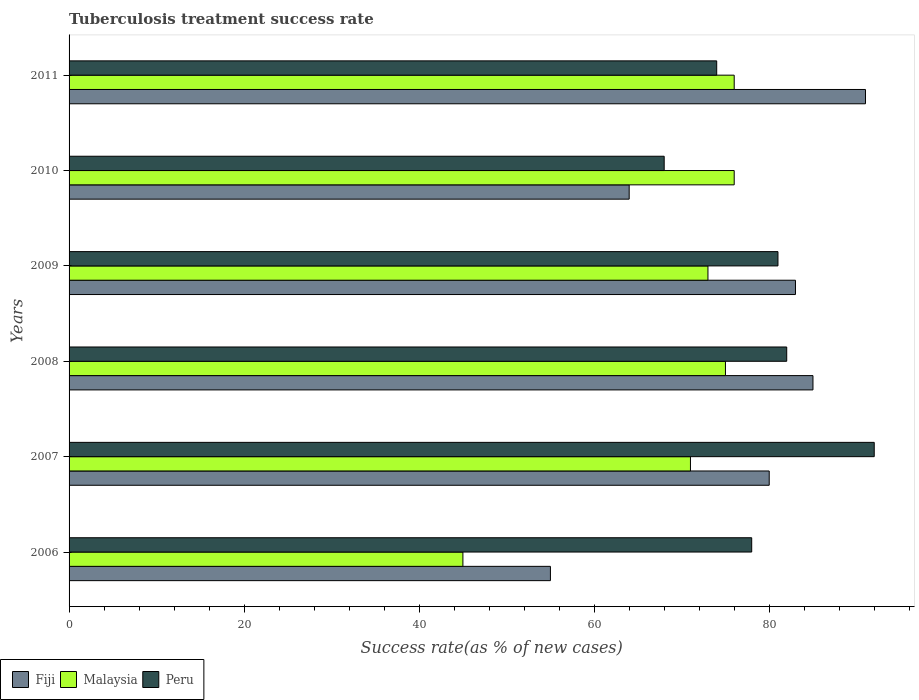Are the number of bars per tick equal to the number of legend labels?
Your answer should be very brief. Yes. What is the label of the 5th group of bars from the top?
Make the answer very short. 2007. In how many cases, is the number of bars for a given year not equal to the number of legend labels?
Your response must be concise. 0. What is the tuberculosis treatment success rate in Fiji in 2006?
Keep it short and to the point. 55. Across all years, what is the maximum tuberculosis treatment success rate in Peru?
Keep it short and to the point. 92. Across all years, what is the minimum tuberculosis treatment success rate in Fiji?
Make the answer very short. 55. In which year was the tuberculosis treatment success rate in Malaysia maximum?
Keep it short and to the point. 2010. What is the total tuberculosis treatment success rate in Peru in the graph?
Your response must be concise. 475. What is the difference between the tuberculosis treatment success rate in Peru in 2008 and that in 2011?
Your answer should be very brief. 8. What is the average tuberculosis treatment success rate in Fiji per year?
Provide a succinct answer. 76.33. In the year 2011, what is the difference between the tuberculosis treatment success rate in Malaysia and tuberculosis treatment success rate in Peru?
Your response must be concise. 2. In how many years, is the tuberculosis treatment success rate in Fiji greater than 32 %?
Offer a terse response. 6. What is the ratio of the tuberculosis treatment success rate in Fiji in 2009 to that in 2010?
Make the answer very short. 1.3. Is the difference between the tuberculosis treatment success rate in Malaysia in 2007 and 2009 greater than the difference between the tuberculosis treatment success rate in Peru in 2007 and 2009?
Keep it short and to the point. No. What is the difference between the highest and the lowest tuberculosis treatment success rate in Peru?
Your answer should be compact. 24. In how many years, is the tuberculosis treatment success rate in Fiji greater than the average tuberculosis treatment success rate in Fiji taken over all years?
Provide a short and direct response. 4. Is the sum of the tuberculosis treatment success rate in Peru in 2006 and 2010 greater than the maximum tuberculosis treatment success rate in Malaysia across all years?
Your answer should be compact. Yes. What does the 3rd bar from the bottom in 2007 represents?
Make the answer very short. Peru. Is it the case that in every year, the sum of the tuberculosis treatment success rate in Peru and tuberculosis treatment success rate in Malaysia is greater than the tuberculosis treatment success rate in Fiji?
Provide a short and direct response. Yes. Are all the bars in the graph horizontal?
Your answer should be compact. Yes. How many years are there in the graph?
Your answer should be compact. 6. What is the difference between two consecutive major ticks on the X-axis?
Your answer should be compact. 20. Where does the legend appear in the graph?
Provide a short and direct response. Bottom left. How many legend labels are there?
Provide a short and direct response. 3. How are the legend labels stacked?
Ensure brevity in your answer.  Horizontal. What is the title of the graph?
Make the answer very short. Tuberculosis treatment success rate. Does "Liechtenstein" appear as one of the legend labels in the graph?
Your answer should be compact. No. What is the label or title of the X-axis?
Keep it short and to the point. Success rate(as % of new cases). What is the Success rate(as % of new cases) of Fiji in 2006?
Your response must be concise. 55. What is the Success rate(as % of new cases) of Fiji in 2007?
Offer a very short reply. 80. What is the Success rate(as % of new cases) of Malaysia in 2007?
Provide a short and direct response. 71. What is the Success rate(as % of new cases) of Peru in 2007?
Your response must be concise. 92. What is the Success rate(as % of new cases) of Malaysia in 2008?
Provide a succinct answer. 75. What is the Success rate(as % of new cases) of Malaysia in 2009?
Provide a short and direct response. 73. What is the Success rate(as % of new cases) in Peru in 2010?
Provide a short and direct response. 68. What is the Success rate(as % of new cases) in Fiji in 2011?
Your answer should be compact. 91. What is the Success rate(as % of new cases) of Malaysia in 2011?
Provide a succinct answer. 76. What is the Success rate(as % of new cases) of Peru in 2011?
Your answer should be very brief. 74. Across all years, what is the maximum Success rate(as % of new cases) of Fiji?
Your response must be concise. 91. Across all years, what is the maximum Success rate(as % of new cases) in Malaysia?
Keep it short and to the point. 76. Across all years, what is the maximum Success rate(as % of new cases) of Peru?
Offer a very short reply. 92. Across all years, what is the minimum Success rate(as % of new cases) in Fiji?
Offer a terse response. 55. Across all years, what is the minimum Success rate(as % of new cases) of Peru?
Provide a short and direct response. 68. What is the total Success rate(as % of new cases) of Fiji in the graph?
Offer a terse response. 458. What is the total Success rate(as % of new cases) of Malaysia in the graph?
Your response must be concise. 416. What is the total Success rate(as % of new cases) in Peru in the graph?
Keep it short and to the point. 475. What is the difference between the Success rate(as % of new cases) in Fiji in 2006 and that in 2008?
Provide a short and direct response. -30. What is the difference between the Success rate(as % of new cases) in Peru in 2006 and that in 2008?
Offer a terse response. -4. What is the difference between the Success rate(as % of new cases) of Fiji in 2006 and that in 2009?
Provide a short and direct response. -28. What is the difference between the Success rate(as % of new cases) of Malaysia in 2006 and that in 2010?
Give a very brief answer. -31. What is the difference between the Success rate(as % of new cases) in Fiji in 2006 and that in 2011?
Provide a short and direct response. -36. What is the difference between the Success rate(as % of new cases) of Malaysia in 2006 and that in 2011?
Offer a terse response. -31. What is the difference between the Success rate(as % of new cases) of Fiji in 2007 and that in 2008?
Provide a succinct answer. -5. What is the difference between the Success rate(as % of new cases) in Peru in 2007 and that in 2008?
Make the answer very short. 10. What is the difference between the Success rate(as % of new cases) of Malaysia in 2007 and that in 2009?
Make the answer very short. -2. What is the difference between the Success rate(as % of new cases) of Peru in 2007 and that in 2009?
Give a very brief answer. 11. What is the difference between the Success rate(as % of new cases) of Fiji in 2007 and that in 2010?
Your response must be concise. 16. What is the difference between the Success rate(as % of new cases) of Fiji in 2007 and that in 2011?
Provide a succinct answer. -11. What is the difference between the Success rate(as % of new cases) in Malaysia in 2007 and that in 2011?
Keep it short and to the point. -5. What is the difference between the Success rate(as % of new cases) in Fiji in 2008 and that in 2010?
Offer a very short reply. 21. What is the difference between the Success rate(as % of new cases) of Malaysia in 2008 and that in 2010?
Keep it short and to the point. -1. What is the difference between the Success rate(as % of new cases) in Peru in 2008 and that in 2010?
Offer a very short reply. 14. What is the difference between the Success rate(as % of new cases) of Fiji in 2008 and that in 2011?
Offer a terse response. -6. What is the difference between the Success rate(as % of new cases) in Malaysia in 2008 and that in 2011?
Offer a terse response. -1. What is the difference between the Success rate(as % of new cases) of Peru in 2008 and that in 2011?
Give a very brief answer. 8. What is the difference between the Success rate(as % of new cases) in Fiji in 2009 and that in 2010?
Offer a terse response. 19. What is the difference between the Success rate(as % of new cases) in Malaysia in 2009 and that in 2010?
Provide a short and direct response. -3. What is the difference between the Success rate(as % of new cases) of Peru in 2009 and that in 2010?
Give a very brief answer. 13. What is the difference between the Success rate(as % of new cases) in Fiji in 2009 and that in 2011?
Provide a succinct answer. -8. What is the difference between the Success rate(as % of new cases) of Peru in 2009 and that in 2011?
Your response must be concise. 7. What is the difference between the Success rate(as % of new cases) of Peru in 2010 and that in 2011?
Your answer should be compact. -6. What is the difference between the Success rate(as % of new cases) of Fiji in 2006 and the Success rate(as % of new cases) of Peru in 2007?
Your answer should be compact. -37. What is the difference between the Success rate(as % of new cases) of Malaysia in 2006 and the Success rate(as % of new cases) of Peru in 2007?
Make the answer very short. -47. What is the difference between the Success rate(as % of new cases) of Fiji in 2006 and the Success rate(as % of new cases) of Malaysia in 2008?
Offer a terse response. -20. What is the difference between the Success rate(as % of new cases) in Malaysia in 2006 and the Success rate(as % of new cases) in Peru in 2008?
Offer a terse response. -37. What is the difference between the Success rate(as % of new cases) of Fiji in 2006 and the Success rate(as % of new cases) of Peru in 2009?
Give a very brief answer. -26. What is the difference between the Success rate(as % of new cases) of Malaysia in 2006 and the Success rate(as % of new cases) of Peru in 2009?
Provide a short and direct response. -36. What is the difference between the Success rate(as % of new cases) of Fiji in 2006 and the Success rate(as % of new cases) of Malaysia in 2010?
Make the answer very short. -21. What is the difference between the Success rate(as % of new cases) of Fiji in 2006 and the Success rate(as % of new cases) of Peru in 2010?
Provide a short and direct response. -13. What is the difference between the Success rate(as % of new cases) of Malaysia in 2006 and the Success rate(as % of new cases) of Peru in 2010?
Ensure brevity in your answer.  -23. What is the difference between the Success rate(as % of new cases) in Fiji in 2006 and the Success rate(as % of new cases) in Malaysia in 2011?
Provide a short and direct response. -21. What is the difference between the Success rate(as % of new cases) in Fiji in 2006 and the Success rate(as % of new cases) in Peru in 2011?
Provide a succinct answer. -19. What is the difference between the Success rate(as % of new cases) of Fiji in 2007 and the Success rate(as % of new cases) of Malaysia in 2008?
Provide a short and direct response. 5. What is the difference between the Success rate(as % of new cases) in Fiji in 2007 and the Success rate(as % of new cases) in Peru in 2008?
Your response must be concise. -2. What is the difference between the Success rate(as % of new cases) in Fiji in 2007 and the Success rate(as % of new cases) in Peru in 2009?
Offer a terse response. -1. What is the difference between the Success rate(as % of new cases) in Malaysia in 2007 and the Success rate(as % of new cases) in Peru in 2009?
Keep it short and to the point. -10. What is the difference between the Success rate(as % of new cases) of Fiji in 2007 and the Success rate(as % of new cases) of Malaysia in 2010?
Your answer should be very brief. 4. What is the difference between the Success rate(as % of new cases) of Fiji in 2007 and the Success rate(as % of new cases) of Malaysia in 2011?
Offer a very short reply. 4. What is the difference between the Success rate(as % of new cases) of Malaysia in 2007 and the Success rate(as % of new cases) of Peru in 2011?
Your response must be concise. -3. What is the difference between the Success rate(as % of new cases) in Fiji in 2008 and the Success rate(as % of new cases) in Malaysia in 2009?
Offer a terse response. 12. What is the difference between the Success rate(as % of new cases) of Malaysia in 2008 and the Success rate(as % of new cases) of Peru in 2009?
Offer a very short reply. -6. What is the difference between the Success rate(as % of new cases) in Fiji in 2008 and the Success rate(as % of new cases) in Peru in 2010?
Make the answer very short. 17. What is the difference between the Success rate(as % of new cases) of Malaysia in 2008 and the Success rate(as % of new cases) of Peru in 2010?
Make the answer very short. 7. What is the difference between the Success rate(as % of new cases) in Fiji in 2008 and the Success rate(as % of new cases) in Malaysia in 2011?
Give a very brief answer. 9. What is the difference between the Success rate(as % of new cases) of Fiji in 2008 and the Success rate(as % of new cases) of Peru in 2011?
Your response must be concise. 11. What is the difference between the Success rate(as % of new cases) of Malaysia in 2008 and the Success rate(as % of new cases) of Peru in 2011?
Offer a terse response. 1. What is the difference between the Success rate(as % of new cases) of Fiji in 2009 and the Success rate(as % of new cases) of Peru in 2010?
Make the answer very short. 15. What is the difference between the Success rate(as % of new cases) of Fiji in 2009 and the Success rate(as % of new cases) of Peru in 2011?
Give a very brief answer. 9. What is the difference between the Success rate(as % of new cases) of Malaysia in 2010 and the Success rate(as % of new cases) of Peru in 2011?
Your answer should be compact. 2. What is the average Success rate(as % of new cases) in Fiji per year?
Keep it short and to the point. 76.33. What is the average Success rate(as % of new cases) of Malaysia per year?
Offer a terse response. 69.33. What is the average Success rate(as % of new cases) in Peru per year?
Ensure brevity in your answer.  79.17. In the year 2006, what is the difference between the Success rate(as % of new cases) in Malaysia and Success rate(as % of new cases) in Peru?
Your answer should be very brief. -33. In the year 2007, what is the difference between the Success rate(as % of new cases) in Fiji and Success rate(as % of new cases) in Malaysia?
Keep it short and to the point. 9. In the year 2007, what is the difference between the Success rate(as % of new cases) of Fiji and Success rate(as % of new cases) of Peru?
Keep it short and to the point. -12. In the year 2007, what is the difference between the Success rate(as % of new cases) in Malaysia and Success rate(as % of new cases) in Peru?
Offer a very short reply. -21. In the year 2008, what is the difference between the Success rate(as % of new cases) of Fiji and Success rate(as % of new cases) of Malaysia?
Your answer should be compact. 10. In the year 2008, what is the difference between the Success rate(as % of new cases) of Fiji and Success rate(as % of new cases) of Peru?
Provide a short and direct response. 3. In the year 2008, what is the difference between the Success rate(as % of new cases) in Malaysia and Success rate(as % of new cases) in Peru?
Offer a very short reply. -7. In the year 2009, what is the difference between the Success rate(as % of new cases) of Fiji and Success rate(as % of new cases) of Peru?
Your answer should be very brief. 2. In the year 2010, what is the difference between the Success rate(as % of new cases) in Malaysia and Success rate(as % of new cases) in Peru?
Ensure brevity in your answer.  8. In the year 2011, what is the difference between the Success rate(as % of new cases) in Malaysia and Success rate(as % of new cases) in Peru?
Make the answer very short. 2. What is the ratio of the Success rate(as % of new cases) in Fiji in 2006 to that in 2007?
Offer a terse response. 0.69. What is the ratio of the Success rate(as % of new cases) in Malaysia in 2006 to that in 2007?
Your answer should be compact. 0.63. What is the ratio of the Success rate(as % of new cases) in Peru in 2006 to that in 2007?
Make the answer very short. 0.85. What is the ratio of the Success rate(as % of new cases) of Fiji in 2006 to that in 2008?
Your answer should be compact. 0.65. What is the ratio of the Success rate(as % of new cases) in Malaysia in 2006 to that in 2008?
Ensure brevity in your answer.  0.6. What is the ratio of the Success rate(as % of new cases) of Peru in 2006 to that in 2008?
Offer a terse response. 0.95. What is the ratio of the Success rate(as % of new cases) in Fiji in 2006 to that in 2009?
Make the answer very short. 0.66. What is the ratio of the Success rate(as % of new cases) of Malaysia in 2006 to that in 2009?
Keep it short and to the point. 0.62. What is the ratio of the Success rate(as % of new cases) in Peru in 2006 to that in 2009?
Provide a succinct answer. 0.96. What is the ratio of the Success rate(as % of new cases) in Fiji in 2006 to that in 2010?
Your answer should be very brief. 0.86. What is the ratio of the Success rate(as % of new cases) in Malaysia in 2006 to that in 2010?
Make the answer very short. 0.59. What is the ratio of the Success rate(as % of new cases) of Peru in 2006 to that in 2010?
Provide a succinct answer. 1.15. What is the ratio of the Success rate(as % of new cases) of Fiji in 2006 to that in 2011?
Make the answer very short. 0.6. What is the ratio of the Success rate(as % of new cases) in Malaysia in 2006 to that in 2011?
Your answer should be very brief. 0.59. What is the ratio of the Success rate(as % of new cases) of Peru in 2006 to that in 2011?
Ensure brevity in your answer.  1.05. What is the ratio of the Success rate(as % of new cases) of Fiji in 2007 to that in 2008?
Give a very brief answer. 0.94. What is the ratio of the Success rate(as % of new cases) in Malaysia in 2007 to that in 2008?
Your response must be concise. 0.95. What is the ratio of the Success rate(as % of new cases) of Peru in 2007 to that in 2008?
Your answer should be very brief. 1.12. What is the ratio of the Success rate(as % of new cases) of Fiji in 2007 to that in 2009?
Your answer should be compact. 0.96. What is the ratio of the Success rate(as % of new cases) in Malaysia in 2007 to that in 2009?
Your response must be concise. 0.97. What is the ratio of the Success rate(as % of new cases) of Peru in 2007 to that in 2009?
Ensure brevity in your answer.  1.14. What is the ratio of the Success rate(as % of new cases) of Malaysia in 2007 to that in 2010?
Give a very brief answer. 0.93. What is the ratio of the Success rate(as % of new cases) of Peru in 2007 to that in 2010?
Provide a short and direct response. 1.35. What is the ratio of the Success rate(as % of new cases) of Fiji in 2007 to that in 2011?
Your response must be concise. 0.88. What is the ratio of the Success rate(as % of new cases) of Malaysia in 2007 to that in 2011?
Make the answer very short. 0.93. What is the ratio of the Success rate(as % of new cases) in Peru in 2007 to that in 2011?
Your response must be concise. 1.24. What is the ratio of the Success rate(as % of new cases) of Fiji in 2008 to that in 2009?
Ensure brevity in your answer.  1.02. What is the ratio of the Success rate(as % of new cases) in Malaysia in 2008 to that in 2009?
Your answer should be compact. 1.03. What is the ratio of the Success rate(as % of new cases) in Peru in 2008 to that in 2009?
Your response must be concise. 1.01. What is the ratio of the Success rate(as % of new cases) of Fiji in 2008 to that in 2010?
Ensure brevity in your answer.  1.33. What is the ratio of the Success rate(as % of new cases) in Peru in 2008 to that in 2010?
Ensure brevity in your answer.  1.21. What is the ratio of the Success rate(as % of new cases) in Fiji in 2008 to that in 2011?
Your answer should be very brief. 0.93. What is the ratio of the Success rate(as % of new cases) in Peru in 2008 to that in 2011?
Give a very brief answer. 1.11. What is the ratio of the Success rate(as % of new cases) of Fiji in 2009 to that in 2010?
Your answer should be very brief. 1.3. What is the ratio of the Success rate(as % of new cases) in Malaysia in 2009 to that in 2010?
Your answer should be compact. 0.96. What is the ratio of the Success rate(as % of new cases) in Peru in 2009 to that in 2010?
Offer a terse response. 1.19. What is the ratio of the Success rate(as % of new cases) in Fiji in 2009 to that in 2011?
Offer a very short reply. 0.91. What is the ratio of the Success rate(as % of new cases) in Malaysia in 2009 to that in 2011?
Provide a short and direct response. 0.96. What is the ratio of the Success rate(as % of new cases) in Peru in 2009 to that in 2011?
Offer a terse response. 1.09. What is the ratio of the Success rate(as % of new cases) in Fiji in 2010 to that in 2011?
Your answer should be compact. 0.7. What is the ratio of the Success rate(as % of new cases) of Malaysia in 2010 to that in 2011?
Make the answer very short. 1. What is the ratio of the Success rate(as % of new cases) of Peru in 2010 to that in 2011?
Provide a short and direct response. 0.92. What is the difference between the highest and the lowest Success rate(as % of new cases) in Malaysia?
Keep it short and to the point. 31. 